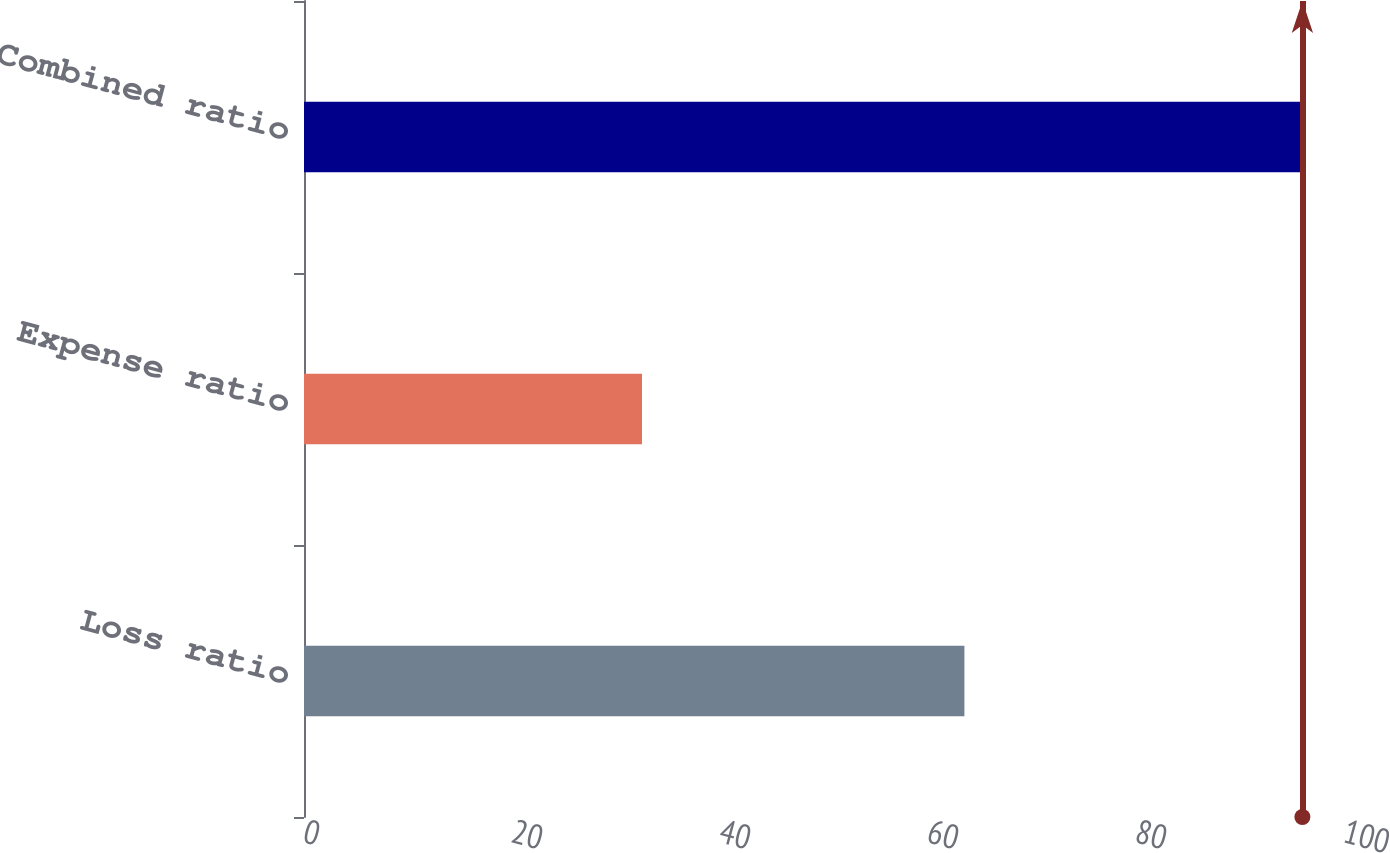Convert chart to OTSL. <chart><loc_0><loc_0><loc_500><loc_500><bar_chart><fcel>Loss ratio<fcel>Expense ratio<fcel>Combined ratio<nl><fcel>63.5<fcel>32.5<fcel>96<nl></chart> 